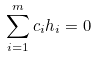Convert formula to latex. <formula><loc_0><loc_0><loc_500><loc_500>\sum _ { i = 1 } ^ { m } c _ { i } h _ { i } = 0</formula> 